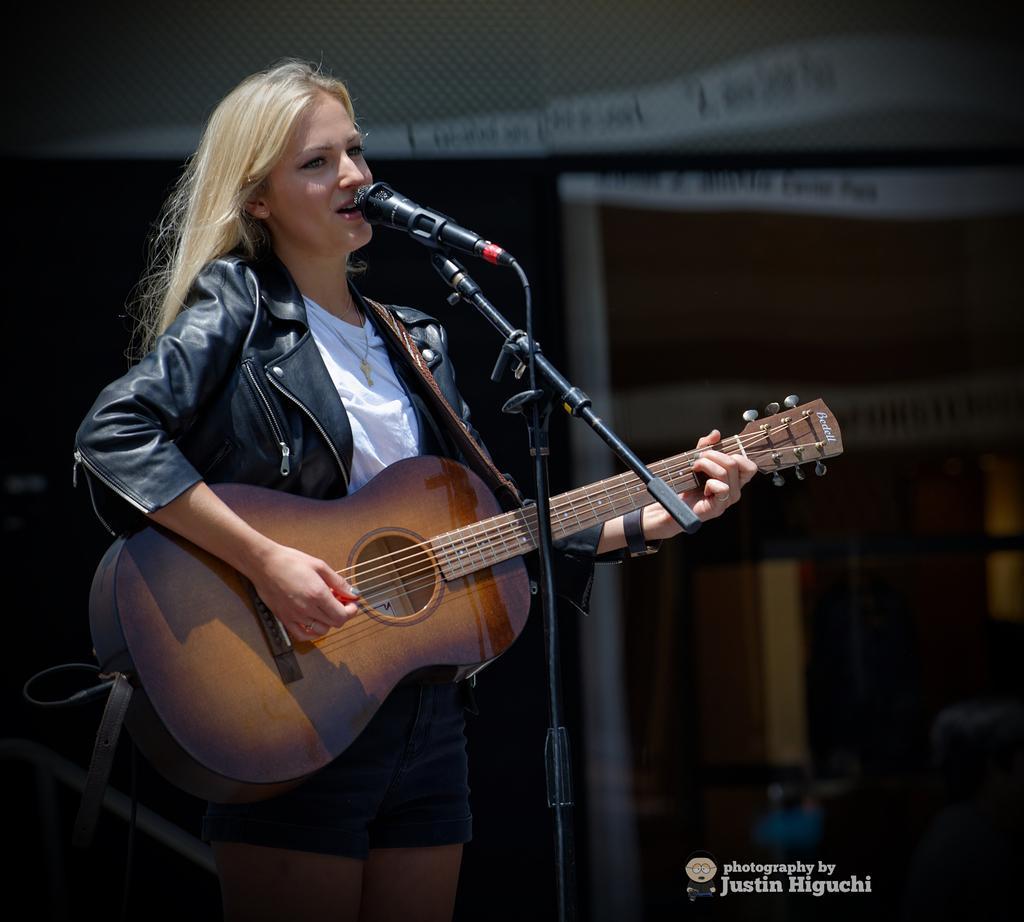Describe this image in one or two sentences. In this image I can see a woman standing in front of the mic and playing guitar. At the back there is a sign board. 